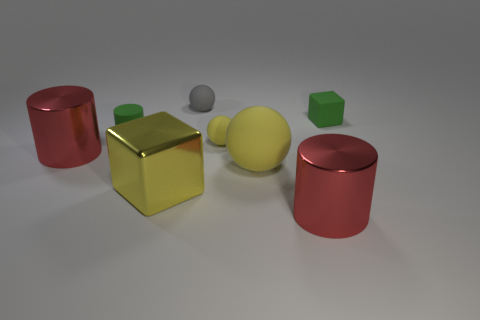Add 1 tiny purple rubber objects. How many objects exist? 9 Subtract all blocks. How many objects are left? 6 Add 5 big red shiny things. How many big red shiny things exist? 7 Subtract 1 green cylinders. How many objects are left? 7 Subtract all large yellow shiny cubes. Subtract all cylinders. How many objects are left? 4 Add 1 large cylinders. How many large cylinders are left? 3 